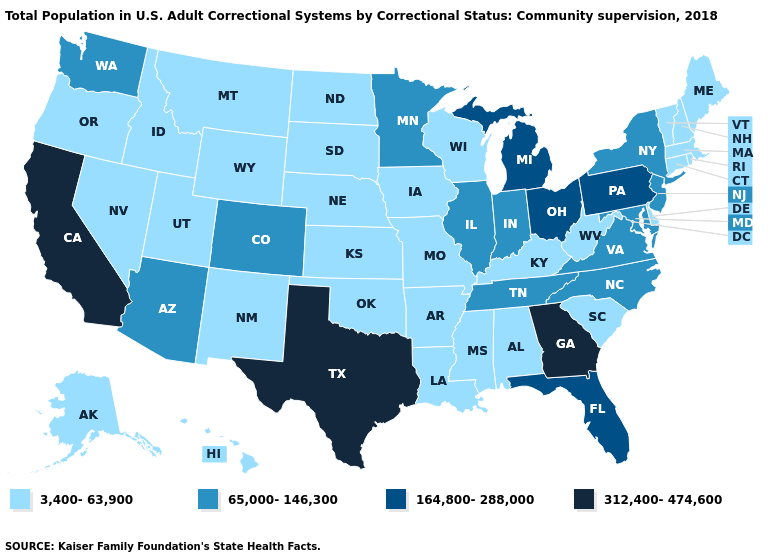Among the states that border Montana , which have the highest value?
Concise answer only. Idaho, North Dakota, South Dakota, Wyoming. Name the states that have a value in the range 164,800-288,000?
Be succinct. Florida, Michigan, Ohio, Pennsylvania. Does California have the highest value in the USA?
Concise answer only. Yes. Which states have the lowest value in the USA?
Be succinct. Alabama, Alaska, Arkansas, Connecticut, Delaware, Hawaii, Idaho, Iowa, Kansas, Kentucky, Louisiana, Maine, Massachusetts, Mississippi, Missouri, Montana, Nebraska, Nevada, New Hampshire, New Mexico, North Dakota, Oklahoma, Oregon, Rhode Island, South Carolina, South Dakota, Utah, Vermont, West Virginia, Wisconsin, Wyoming. Among the states that border Ohio , which have the highest value?
Be succinct. Michigan, Pennsylvania. What is the value of South Dakota?
Answer briefly. 3,400-63,900. What is the value of Kansas?
Quick response, please. 3,400-63,900. Does Florida have a higher value than Georgia?
Be succinct. No. What is the highest value in states that border Mississippi?
Answer briefly. 65,000-146,300. What is the value of Minnesota?
Quick response, please. 65,000-146,300. Is the legend a continuous bar?
Be succinct. No. What is the value of Idaho?
Be succinct. 3,400-63,900. Among the states that border Idaho , which have the highest value?
Be succinct. Washington. What is the value of North Dakota?
Answer briefly. 3,400-63,900. What is the lowest value in the West?
Be succinct. 3,400-63,900. 